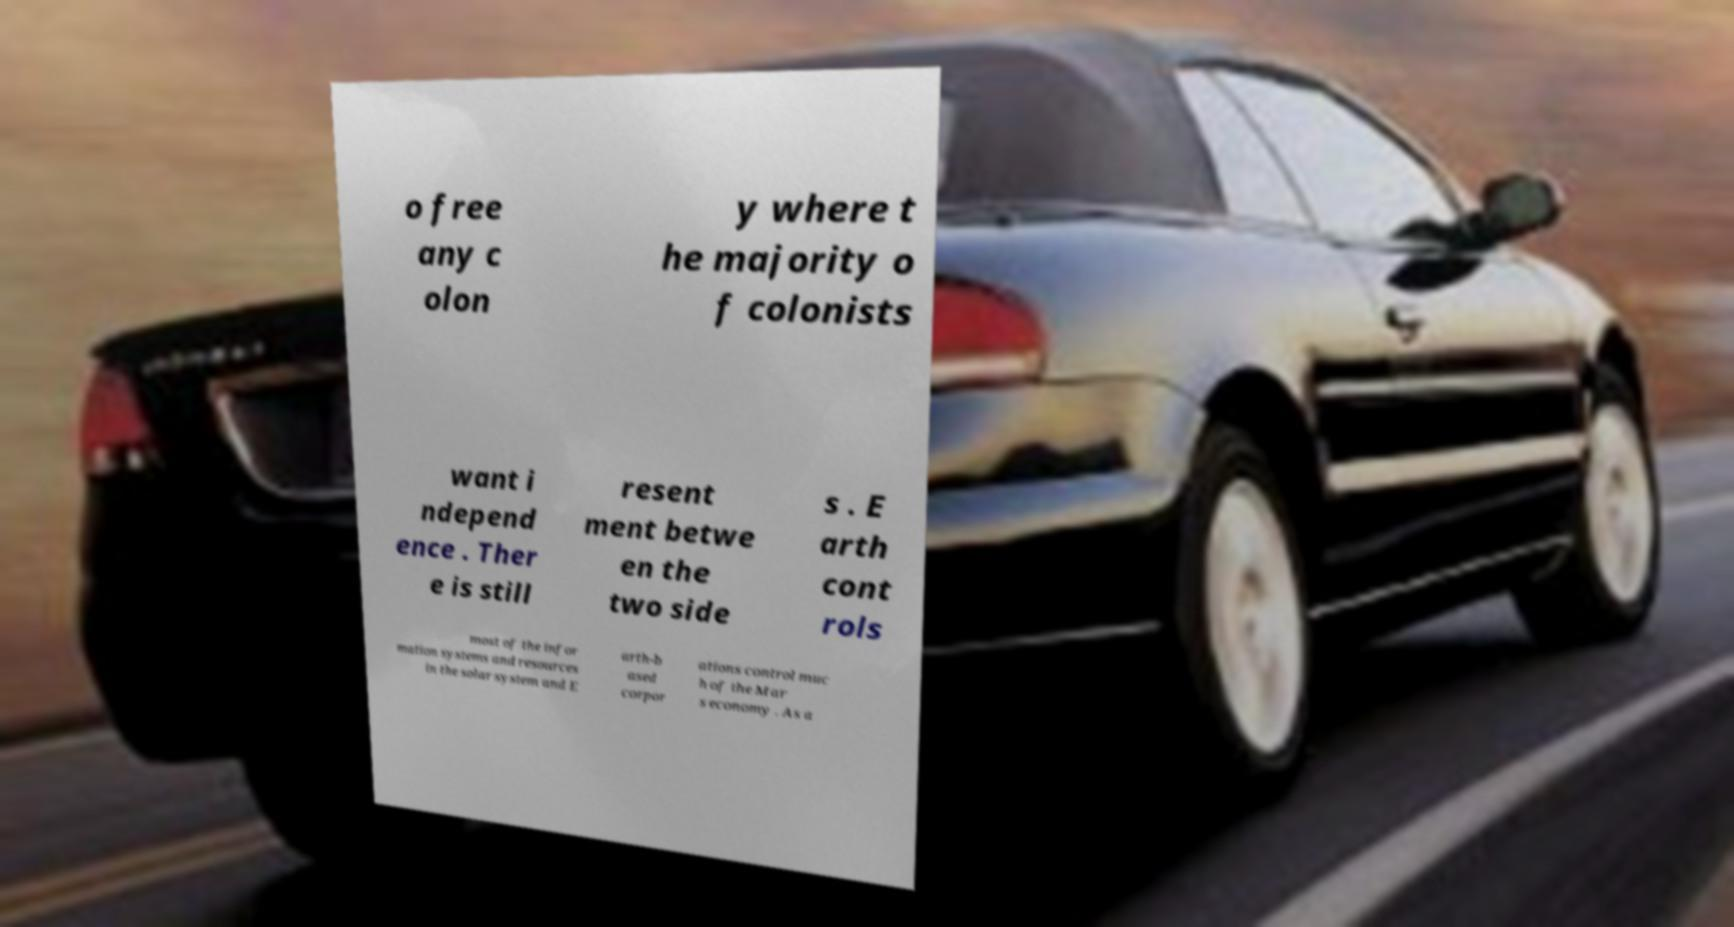Please identify and transcribe the text found in this image. o free any c olon y where t he majority o f colonists want i ndepend ence . Ther e is still resent ment betwe en the two side s . E arth cont rols most of the infor mation systems and resources in the solar system and E arth-b ased corpor ations control muc h of the Mar s economy . As a 